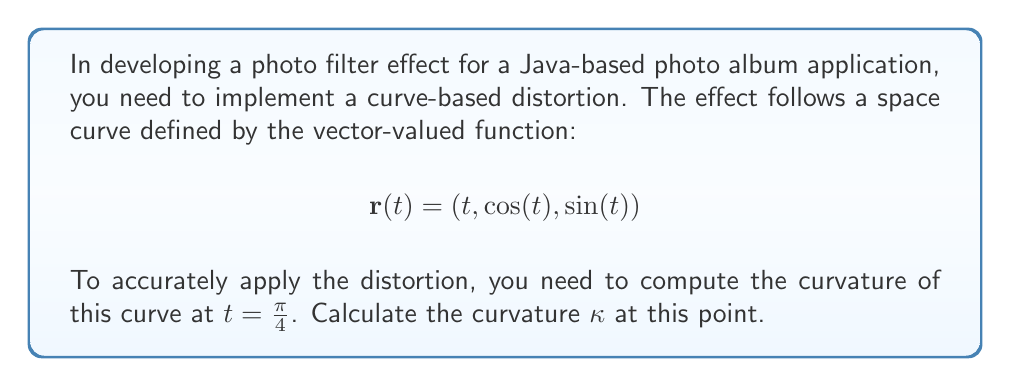Solve this math problem. To compute the curvature of a space curve, we use the formula:

$$\kappa = \frac{|\mathbf{r}'(t) \times \mathbf{r}''(t)|}{|\mathbf{r}'(t)|^3}$$

Let's follow these steps:

1) First, calculate $\mathbf{r}'(t)$:
   $$\mathbf{r}'(t) = (1, -\sin(t), \cos(t))$$

2) Then, calculate $\mathbf{r}''(t)$:
   $$\mathbf{r}''(t) = (0, -\cos(t), -\sin(t))$$

3) At $t = \frac{\pi}{4}$:
   $$\mathbf{r}'(\frac{\pi}{4}) = (1, -\frac{\sqrt{2}}{2}, \frac{\sqrt{2}}{2})$$
   $$\mathbf{r}''(\frac{\pi}{4}) = (0, -\frac{\sqrt{2}}{2}, -\frac{\sqrt{2}}{2})$$

4) Calculate the cross product $\mathbf{r}'(\frac{\pi}{4}) \times \mathbf{r}''(\frac{\pi}{4})$:
   $$\begin{vmatrix} 
   \mathbf{i} & \mathbf{j} & \mathbf{k} \\
   1 & -\frac{\sqrt{2}}{2} & \frac{\sqrt{2}}{2} \\
   0 & -\frac{\sqrt{2}}{2} & -\frac{\sqrt{2}}{2}
   \end{vmatrix}
   = (\frac{1}{2}, \frac{\sqrt{2}}{2}, -\frac{\sqrt{2}}{2})$$

5) Calculate $|\mathbf{r}'(\frac{\pi}{4}) \times \mathbf{r}''(\frac{\pi}{4})|$:
   $$\sqrt{(\frac{1}{2})^2 + (\frac{\sqrt{2}}{2})^2 + (-\frac{\sqrt{2}}{2})^2} = 1$$

6) Calculate $|\mathbf{r}'(\frac{\pi}{4})|$:
   $$\sqrt{1^2 + (-\frac{\sqrt{2}}{2})^2 + (\frac{\sqrt{2}}{2})^2} = \sqrt{2}$$

7) Finally, compute the curvature:
   $$\kappa = \frac{|\mathbf{r}'(\frac{\pi}{4}) \times \mathbf{r}''(\frac{\pi}{4})|}{|\mathbf{r}'(\frac{\pi}{4})|^3} = \frac{1}{(\sqrt{2})^3} = \frac{1}{2\sqrt{2}}$$
Answer: $\kappa = \frac{1}{2\sqrt{2}}$ 